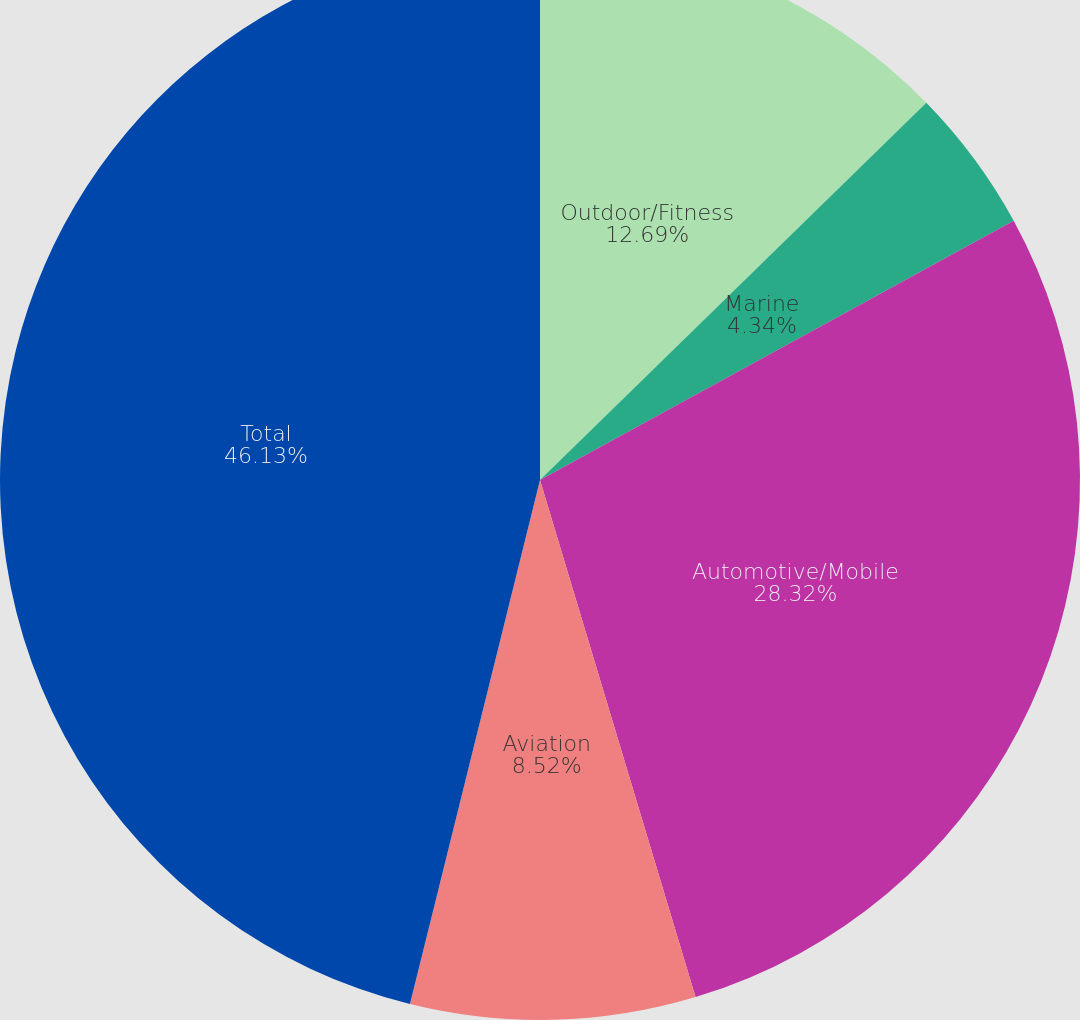Convert chart. <chart><loc_0><loc_0><loc_500><loc_500><pie_chart><fcel>Outdoor/Fitness<fcel>Marine<fcel>Automotive/Mobile<fcel>Aviation<fcel>Total<nl><fcel>12.69%<fcel>4.34%<fcel>28.32%<fcel>8.52%<fcel>46.13%<nl></chart> 